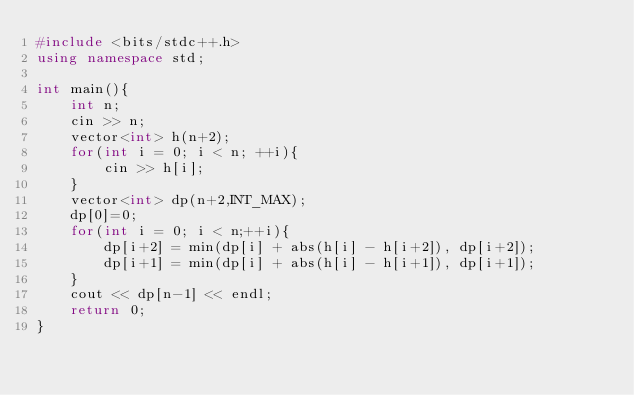<code> <loc_0><loc_0><loc_500><loc_500><_C++_>#include <bits/stdc++.h>
using namespace std;

int main(){
	int n;
	cin >> n;
	vector<int> h(n+2);
	for(int i = 0; i < n; ++i){
		cin >> h[i];
	}
	vector<int> dp(n+2,INT_MAX);
	dp[0]=0;
	for(int i = 0; i < n;++i){
		dp[i+2] = min(dp[i] + abs(h[i] - h[i+2]), dp[i+2]);
		dp[i+1] = min(dp[i] + abs(h[i] - h[i+1]), dp[i+1]);
	}
	cout << dp[n-1] << endl;
	return 0;
}</code> 